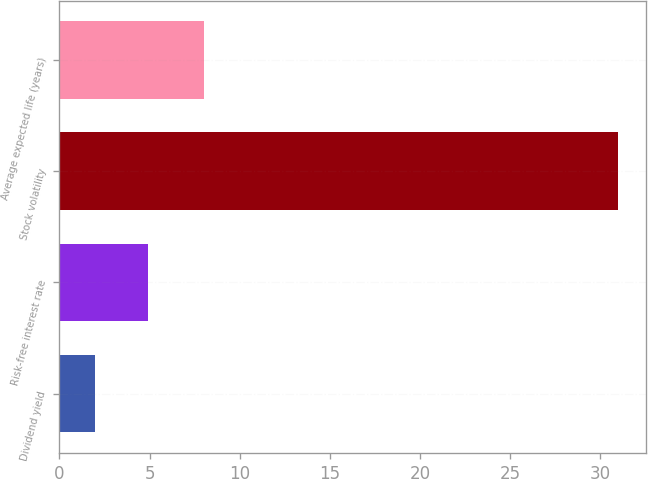<chart> <loc_0><loc_0><loc_500><loc_500><bar_chart><fcel>Dividend yield<fcel>Risk-free interest rate<fcel>Stock volatility<fcel>Average expected life (years)<nl><fcel>2<fcel>4.9<fcel>31<fcel>8<nl></chart> 